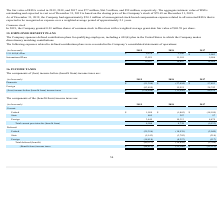From Pegasystems's financial document, What are the respective loss before income tax benefits in 2018 and 2019? The document shows two values: 11,543 and 134,846 (in thousands). From the document: "oss) income before (benefit from) income taxes $ (134,846) $ (11,543) $ 86,235 before (benefit from) income taxes $ (134,846) $ (11,543) $ 86,235..." Also, What are the respective domestic and foreign income before income taxes in 2017? The document shows two values: 57,493 and 28,742 (in thousands). From the document: "Foreign (83,450) 15,951 28,742 Domestic $ (51,396) $ (27,494) $ 57,493..." Also, What are the respective domestic and foreign losses before income tax benefits in 2019? The document shows two values: 51,396 and 83,450 (in thousands). From the document: "Domestic $ (51,396) $ (27,494) $ 57,493 Foreign (83,450) 15,951 28,742..." Also, can you calculate: What is the average loss from domestic and foreign sources in 2019? To answer this question, I need to perform calculations using the financial data. The calculation is: (51,396 + 83,450)/2, which equals 67423 (in thousands). This is based on the information: "Domestic $ (51,396) $ (27,494) $ 57,493 Foreign (83,450) 15,951 28,742..." The key data points involved are: 51,396, 83,450. Also, can you calculate: What is the average loss made by the company in 2018 and 2019? To answer this question, I need to perform calculations using the financial data. The calculation is: (11,543 + 134,846)/2 , which equals 73194.5 (in thousands). This is based on the information: "oss) income before (benefit from) income taxes $ (134,846) $ (11,543) $ 86,235 before (benefit from) income taxes $ (134,846) $ (11,543) $ 86,235..." The key data points involved are: 11,543, 134,846. Also, can you calculate: What is the percentage change in income from foreign sources between 2017 and 2018? To answer this question, I need to perform calculations using the financial data. The calculation is: (15,951 - 28,742)/28,742 , which equals -44.5 (percentage). This is based on the information: "Foreign (83,450) 15,951 28,742 Foreign (83,450) 15,951 28,742..." The key data points involved are: 15,951, 28,742. 